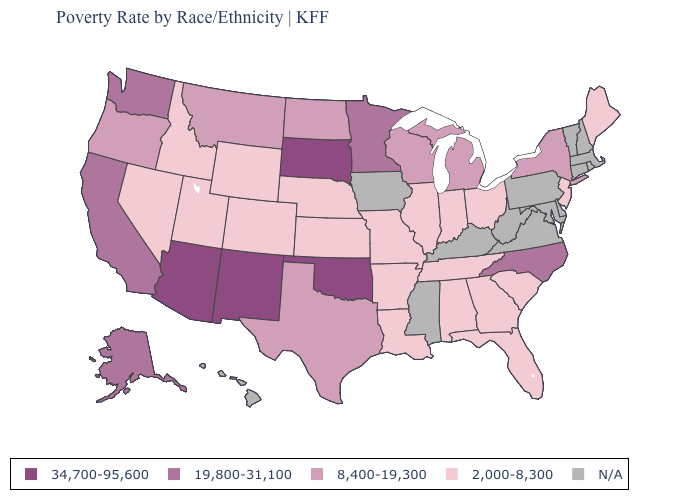Which states have the highest value in the USA?
Answer briefly. Arizona, New Mexico, Oklahoma, South Dakota. What is the value of Delaware?
Quick response, please. N/A. What is the value of Pennsylvania?
Keep it brief. N/A. Does North Carolina have the lowest value in the South?
Answer briefly. No. What is the value of Nevada?
Write a very short answer. 2,000-8,300. Among the states that border Washington , does Oregon have the highest value?
Write a very short answer. Yes. What is the value of Nebraska?
Be succinct. 2,000-8,300. Does the map have missing data?
Answer briefly. Yes. Among the states that border Arkansas , which have the highest value?
Quick response, please. Oklahoma. Which states have the lowest value in the South?
Write a very short answer. Alabama, Arkansas, Florida, Georgia, Louisiana, South Carolina, Tennessee. Name the states that have a value in the range 2,000-8,300?
Quick response, please. Alabama, Arkansas, Colorado, Florida, Georgia, Idaho, Illinois, Indiana, Kansas, Louisiana, Maine, Missouri, Nebraska, Nevada, New Jersey, Ohio, South Carolina, Tennessee, Utah, Wyoming. What is the value of New Mexico?
Short answer required. 34,700-95,600. 